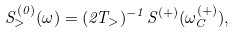<formula> <loc_0><loc_0><loc_500><loc_500>S ^ { ( 0 ) } _ { > } ( \omega ) = ( 2 T _ { > } ) ^ { - 1 } S ^ { ( + ) } ( \omega ^ { ( + ) } _ { C } ) ,</formula> 